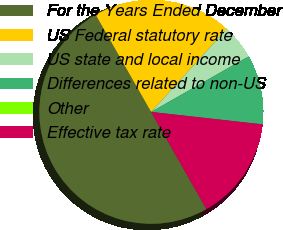<chart> <loc_0><loc_0><loc_500><loc_500><pie_chart><fcel>For the Years Ended December<fcel>US Federal statutory rate<fcel>US state and local income<fcel>Differences related to non-US<fcel>Other<fcel>Effective tax rate<nl><fcel>49.98%<fcel>20.0%<fcel>5.01%<fcel>10.0%<fcel>0.01%<fcel>15.0%<nl></chart> 